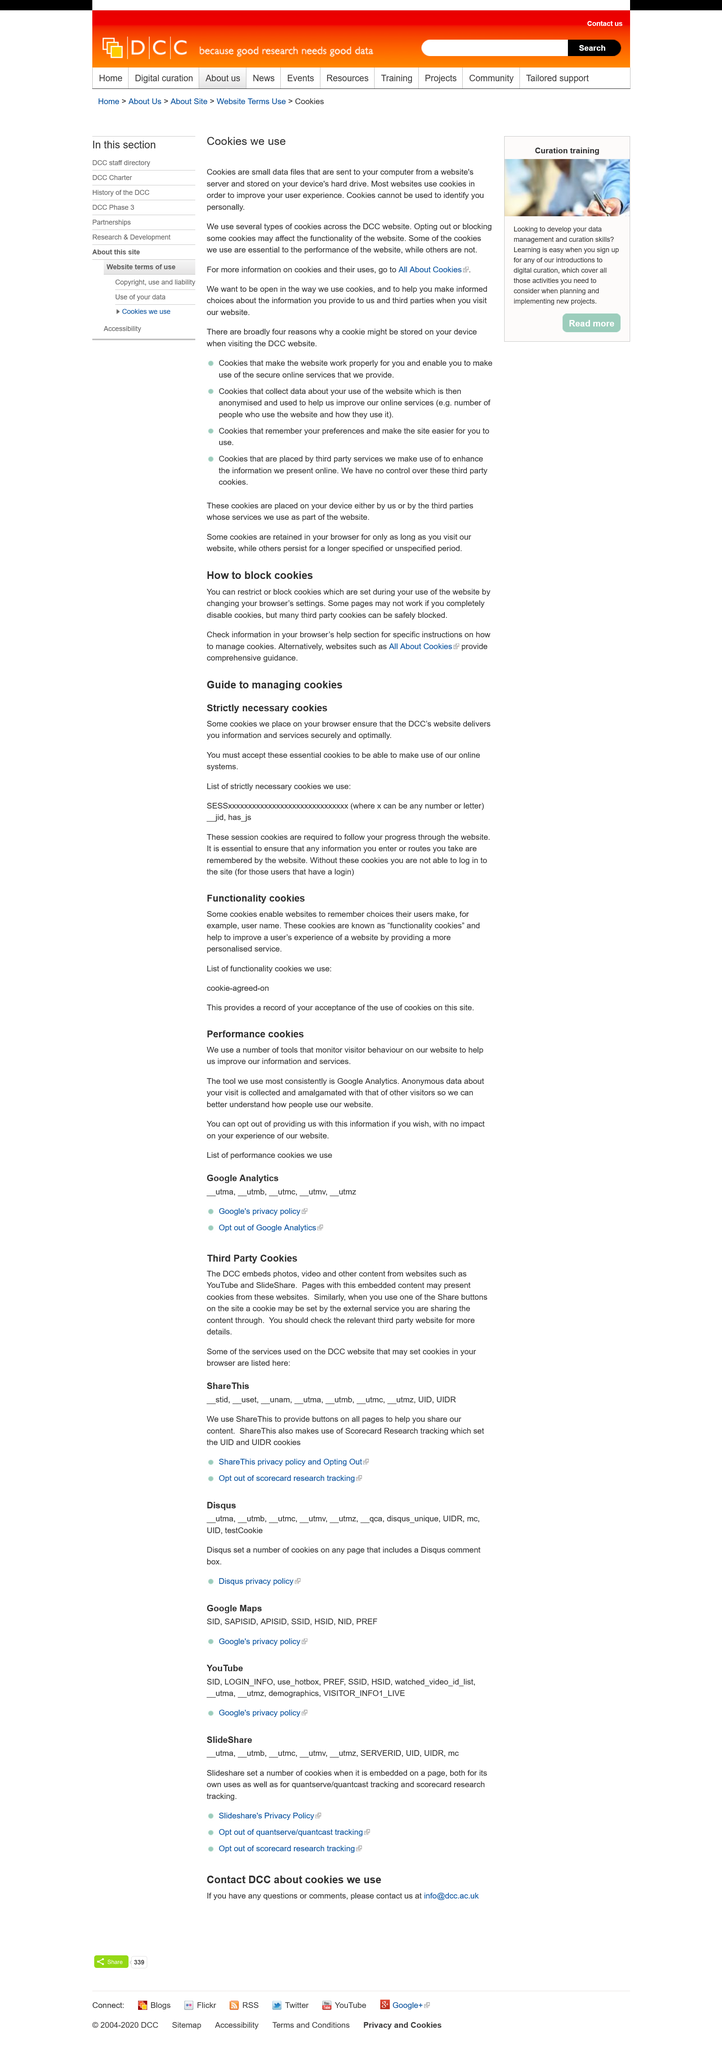List a handful of essential elements in this visual. The purpose of this page is to inform that it is about cookies. The title of the second subheading is "Performance cookies. It is possible to obtain additional information about cookies and their uses by clicking on the hyperlink labeled "All About Cookies. There are two subheadings on this page. Cookies cannot be used to identify individuals personally. 